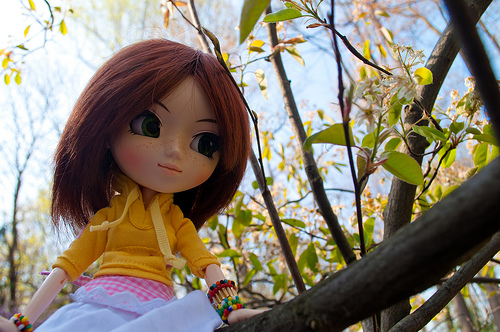<image>
Can you confirm if the leaf is on the branch? No. The leaf is not positioned on the branch. They may be near each other, but the leaf is not supported by or resting on top of the branch. 